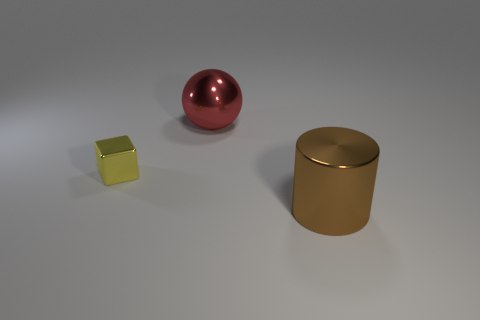Add 3 big spheres. How many objects exist? 6 Subtract all balls. How many objects are left? 2 Add 3 large brown cylinders. How many large brown cylinders exist? 4 Subtract 0 gray cylinders. How many objects are left? 3 Subtract all small metal blocks. Subtract all shiny cubes. How many objects are left? 1 Add 2 red shiny things. How many red shiny things are left? 3 